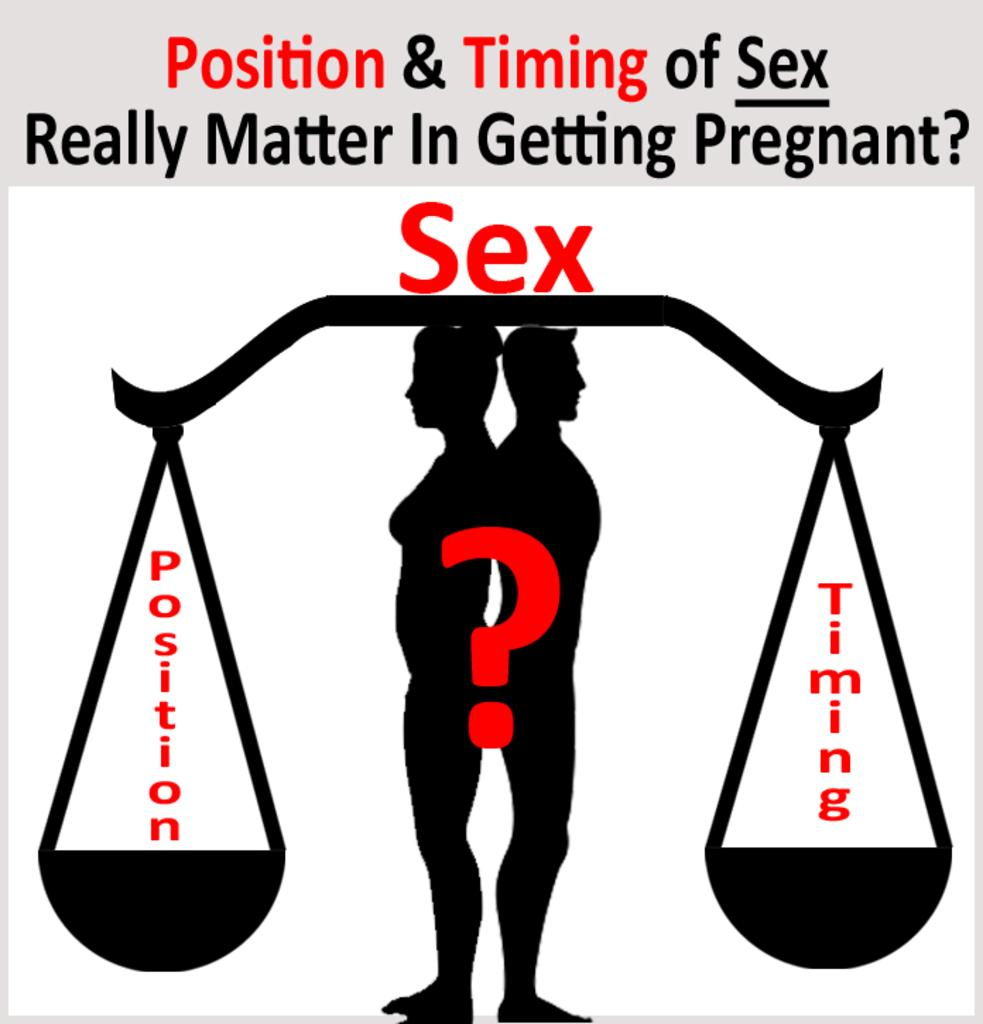<image>
Write a terse but informative summary of the picture. A cartoon drawing of a man and woman with the word SEX printed above them. 